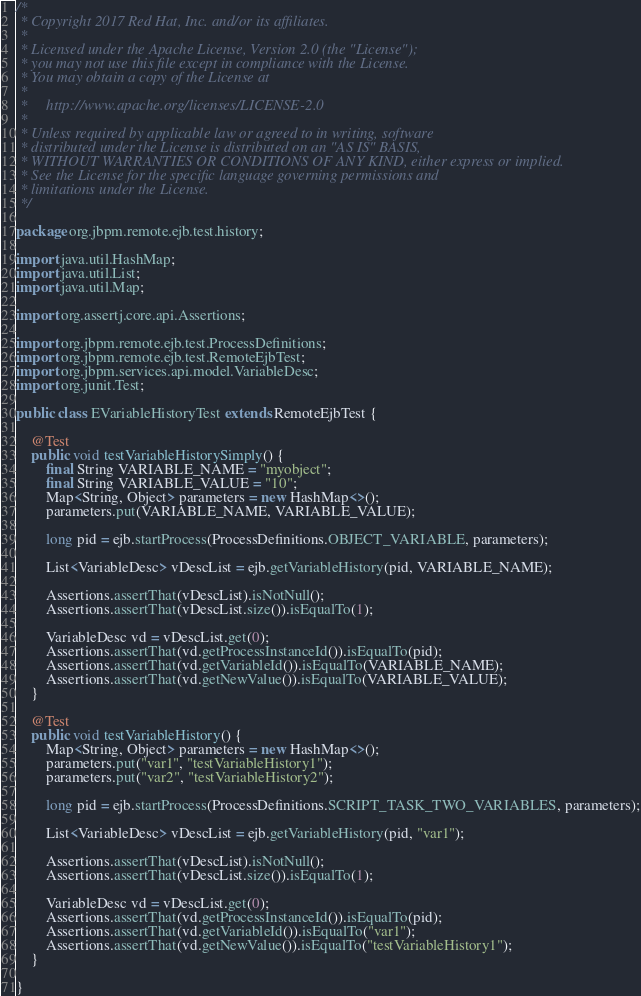Convert code to text. <code><loc_0><loc_0><loc_500><loc_500><_Java_>/*
 * Copyright 2017 Red Hat, Inc. and/or its affiliates.
 *
 * Licensed under the Apache License, Version 2.0 (the "License");
 * you may not use this file except in compliance with the License.
 * You may obtain a copy of the License at
 *
 *     http://www.apache.org/licenses/LICENSE-2.0
 *
 * Unless required by applicable law or agreed to in writing, software
 * distributed under the License is distributed on an "AS IS" BASIS,
 * WITHOUT WARRANTIES OR CONDITIONS OF ANY KIND, either express or implied.
 * See the License for the specific language governing permissions and
 * limitations under the License.
 */

package org.jbpm.remote.ejb.test.history;

import java.util.HashMap;
import java.util.List;
import java.util.Map;

import org.assertj.core.api.Assertions;

import org.jbpm.remote.ejb.test.ProcessDefinitions;
import org.jbpm.remote.ejb.test.RemoteEjbTest;
import org.jbpm.services.api.model.VariableDesc;
import org.junit.Test;

public class EVariableHistoryTest extends RemoteEjbTest {

    @Test
    public void testVariableHistorySimply() {
        final String VARIABLE_NAME = "myobject";
        final String VARIABLE_VALUE = "10";
        Map<String, Object> parameters = new HashMap<>();
        parameters.put(VARIABLE_NAME, VARIABLE_VALUE);

        long pid = ejb.startProcess(ProcessDefinitions.OBJECT_VARIABLE, parameters);

        List<VariableDesc> vDescList = ejb.getVariableHistory(pid, VARIABLE_NAME);

        Assertions.assertThat(vDescList).isNotNull();
        Assertions.assertThat(vDescList.size()).isEqualTo(1);

        VariableDesc vd = vDescList.get(0);
        Assertions.assertThat(vd.getProcessInstanceId()).isEqualTo(pid);
        Assertions.assertThat(vd.getVariableId()).isEqualTo(VARIABLE_NAME);
        Assertions.assertThat(vd.getNewValue()).isEqualTo(VARIABLE_VALUE);
    }

    @Test
    public void testVariableHistory() {
        Map<String, Object> parameters = new HashMap<>();
        parameters.put("var1", "testVariableHistory1");
        parameters.put("var2", "testVariableHistory2");

        long pid = ejb.startProcess(ProcessDefinitions.SCRIPT_TASK_TWO_VARIABLES, parameters);

        List<VariableDesc> vDescList = ejb.getVariableHistory(pid, "var1");

        Assertions.assertThat(vDescList).isNotNull();
        Assertions.assertThat(vDescList.size()).isEqualTo(1);

        VariableDesc vd = vDescList.get(0);
        Assertions.assertThat(vd.getProcessInstanceId()).isEqualTo(pid);
        Assertions.assertThat(vd.getVariableId()).isEqualTo("var1");
        Assertions.assertThat(vd.getNewValue()).isEqualTo("testVariableHistory1");
    }

}
</code> 